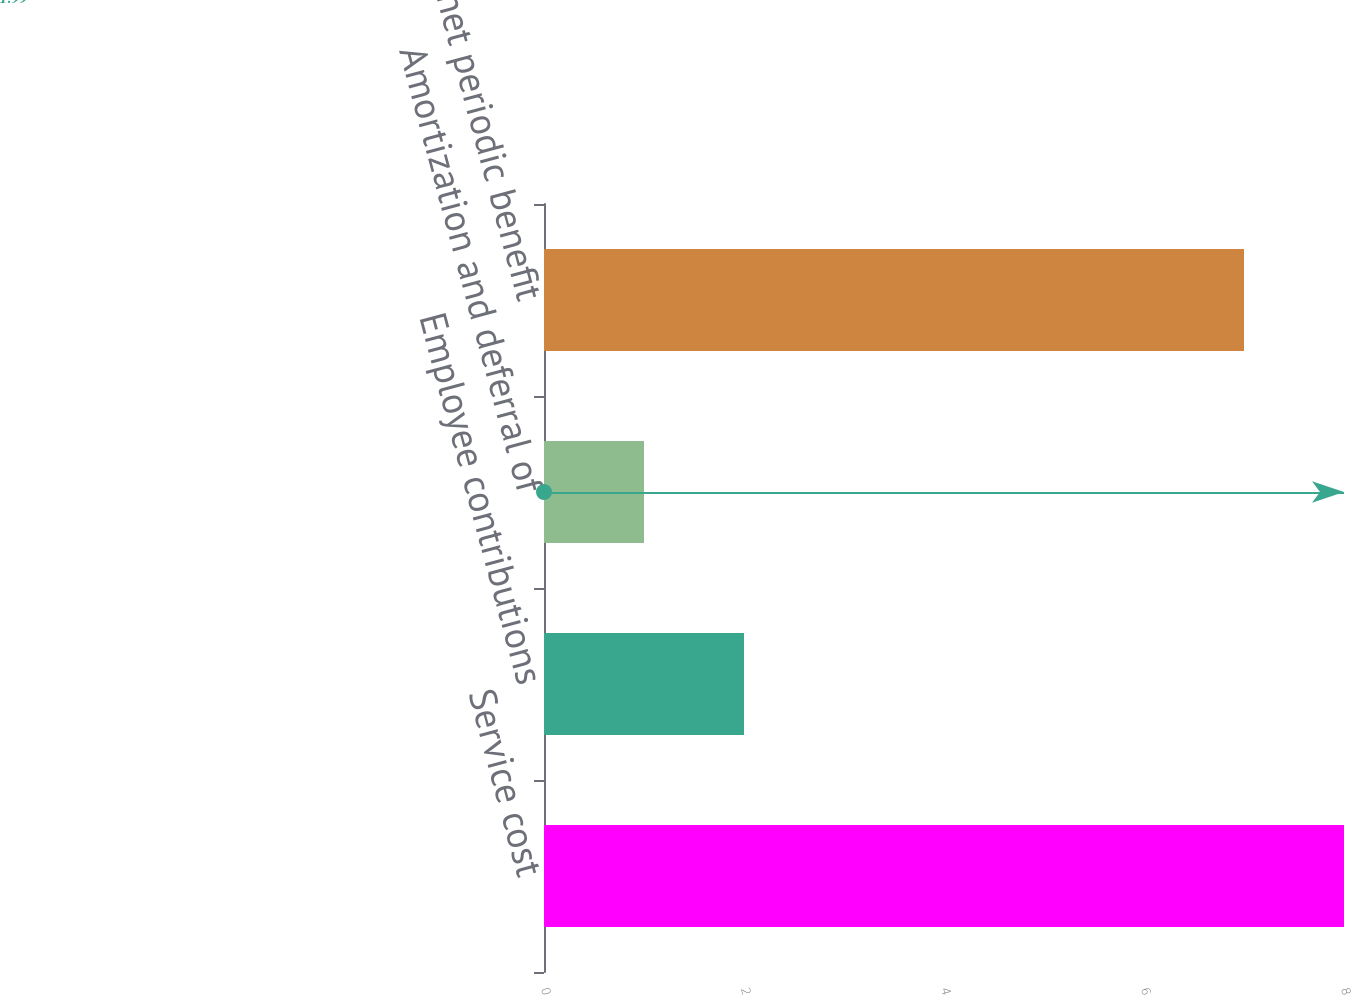Convert chart. <chart><loc_0><loc_0><loc_500><loc_500><bar_chart><fcel>Service cost<fcel>Employee contributions<fcel>Amortization and deferral of<fcel>Total net periodic benefit<nl><fcel>8<fcel>2<fcel>1<fcel>7<nl></chart> 